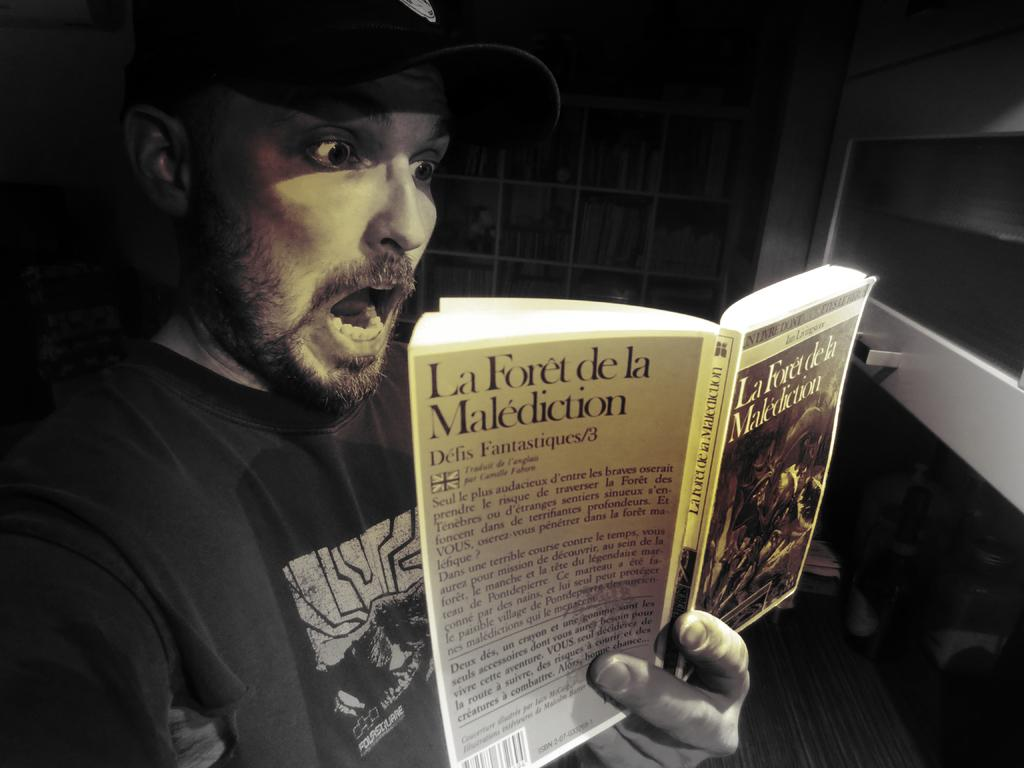What is the person in the image holding? The person is holding a book in the image. What can be seen in the background of the image? There are books in the racks and other items visible in the background of the image. Can you see a key floating in a bubble in the image? No, there is no key or bubble present in the image. 